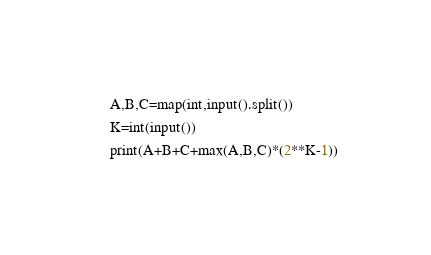Convert code to text. <code><loc_0><loc_0><loc_500><loc_500><_Python_>A,B,C=map(int,input().split())
K=int(input())
print(A+B+C+max(A,B,C)*(2**K-1))</code> 